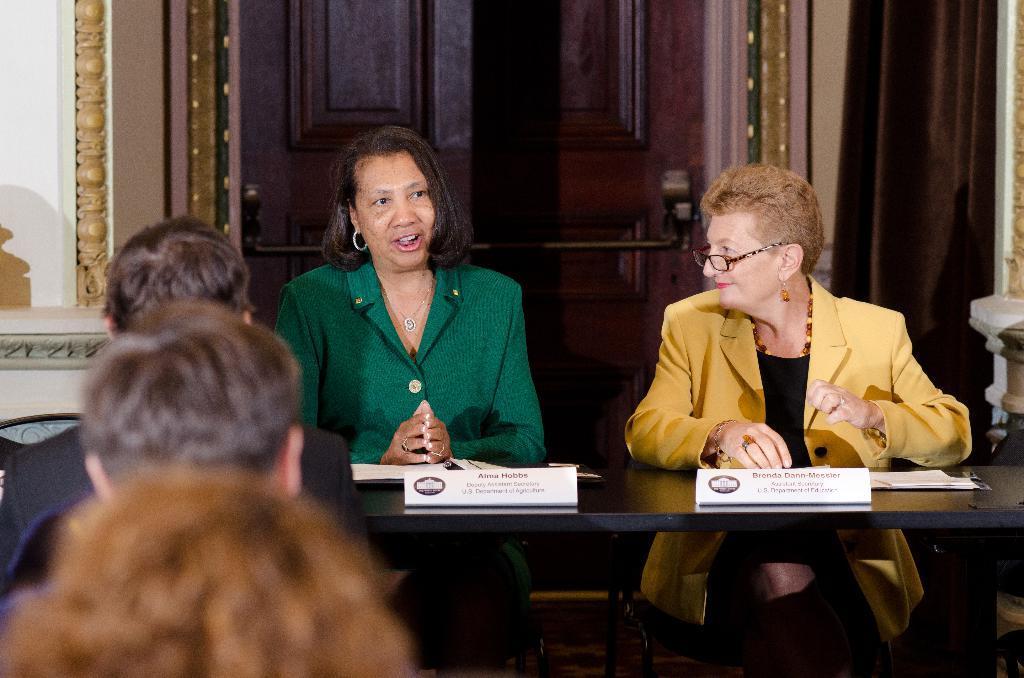Could you give a brief overview of what you see in this image? In the image we can see there are people who are sitting on chair and in front of them there are people who are looking at them. 